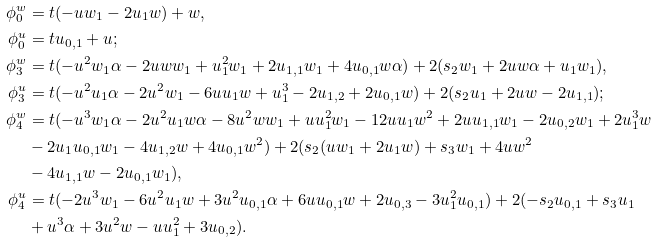Convert formula to latex. <formula><loc_0><loc_0><loc_500><loc_500>\phi ^ { w } _ { 0 } & = t ( - u w _ { 1 } - 2 u _ { 1 } w ) + w , \\ \phi ^ { u } _ { 0 } & = t u _ { 0 , 1 } + u ; \\ \phi ^ { w } _ { 3 } & = t ( - u ^ { 2 } w _ { 1 } \alpha - 2 u w w _ { 1 } + u _ { 1 } ^ { 2 } w _ { 1 } + 2 u _ { 1 , 1 } w _ { 1 } + 4 u _ { 0 , 1 } w \alpha ) + 2 ( s _ { 2 } w _ { 1 } + 2 u w \alpha + u _ { 1 } w _ { 1 } ) , \\ \phi ^ { u } _ { 3 } & = t ( - u ^ { 2 } u _ { 1 } \alpha - 2 u ^ { 2 } w _ { 1 } - 6 u u _ { 1 } w + u _ { 1 } ^ { 3 } - 2 u _ { 1 , 2 } + 2 u _ { 0 , 1 } w ) + 2 ( s _ { 2 } u _ { 1 } + 2 u w - 2 u _ { 1 , 1 } ) ; \\ \phi ^ { w } _ { 4 } & = t ( - u ^ { 3 } w _ { 1 } \alpha - 2 u ^ { 2 } u _ { 1 } w \alpha - 8 u ^ { 2 } w w _ { 1 } + u u _ { 1 } ^ { 2 } w _ { 1 } - 1 2 u u _ { 1 } w ^ { 2 } + 2 u u _ { 1 , 1 } w _ { 1 } - 2 u _ { 0 , 2 } w _ { 1 } + 2 u _ { 1 } ^ { 3 } w \\ & - 2 u _ { 1 } u _ { 0 , 1 } w _ { 1 } - 4 u _ { 1 , 2 } w + 4 u _ { 0 , 1 } w ^ { 2 } ) + 2 ( s _ { 2 } ( u w _ { 1 } + 2 u _ { 1 } w ) + s _ { 3 } w _ { 1 } + 4 u w ^ { 2 } \\ & - 4 u _ { 1 , 1 } w - 2 u _ { 0 , 1 } w _ { 1 } ) , \\ \phi ^ { u } _ { 4 } & = t ( - 2 u ^ { 3 } w _ { 1 } - 6 u ^ { 2 } u _ { 1 } w + 3 u ^ { 2 } u _ { 0 , 1 } \alpha + 6 u u _ { 0 , 1 } w + 2 u _ { 0 , 3 } - 3 u _ { 1 } ^ { 2 } u _ { 0 , 1 } ) + 2 ( - s _ { 2 } u _ { 0 , 1 } + s _ { 3 } u _ { 1 } \\ & + u ^ { 3 } \alpha + 3 u ^ { 2 } w - u u _ { 1 } ^ { 2 } + 3 u _ { 0 , 2 } ) .</formula> 